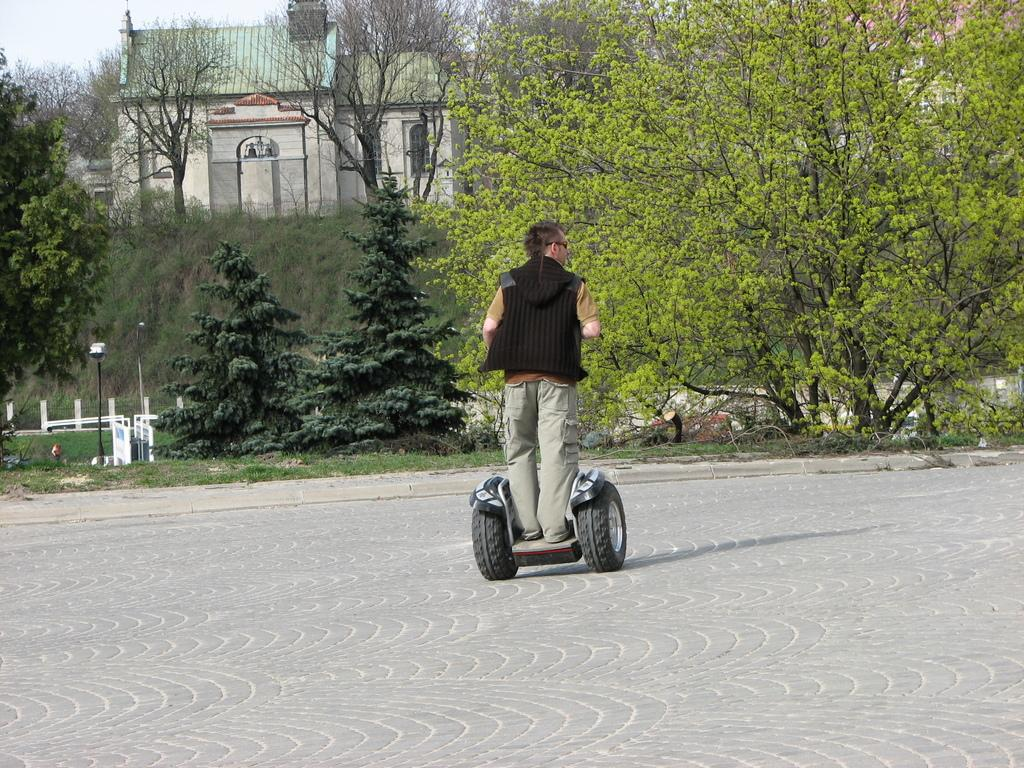What is the person in the image doing? The person is standing on a Segway in the image. What is the person wearing? The person is wearing a black t-shirt and grey pants. What can be seen in the background of the image? There are many trees and a building in the background of the image. How many tigers can be seen sleeping on the beds in the image? There are no tigers or beds present in the image. 